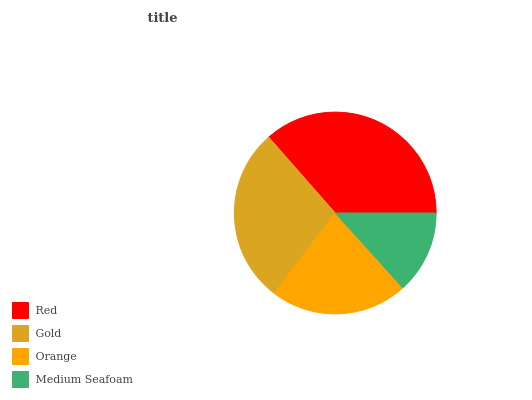Is Medium Seafoam the minimum?
Answer yes or no. Yes. Is Red the maximum?
Answer yes or no. Yes. Is Gold the minimum?
Answer yes or no. No. Is Gold the maximum?
Answer yes or no. No. Is Red greater than Gold?
Answer yes or no. Yes. Is Gold less than Red?
Answer yes or no. Yes. Is Gold greater than Red?
Answer yes or no. No. Is Red less than Gold?
Answer yes or no. No. Is Gold the high median?
Answer yes or no. Yes. Is Orange the low median?
Answer yes or no. Yes. Is Medium Seafoam the high median?
Answer yes or no. No. Is Red the low median?
Answer yes or no. No. 